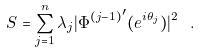<formula> <loc_0><loc_0><loc_500><loc_500>S = \sum _ { j = 1 } ^ { n } \lambda _ { j } | { \Phi ^ { ( j - 1 ) } } ^ { \prime } ( e ^ { i \theta _ { j } } ) | ^ { 2 } \ .</formula> 